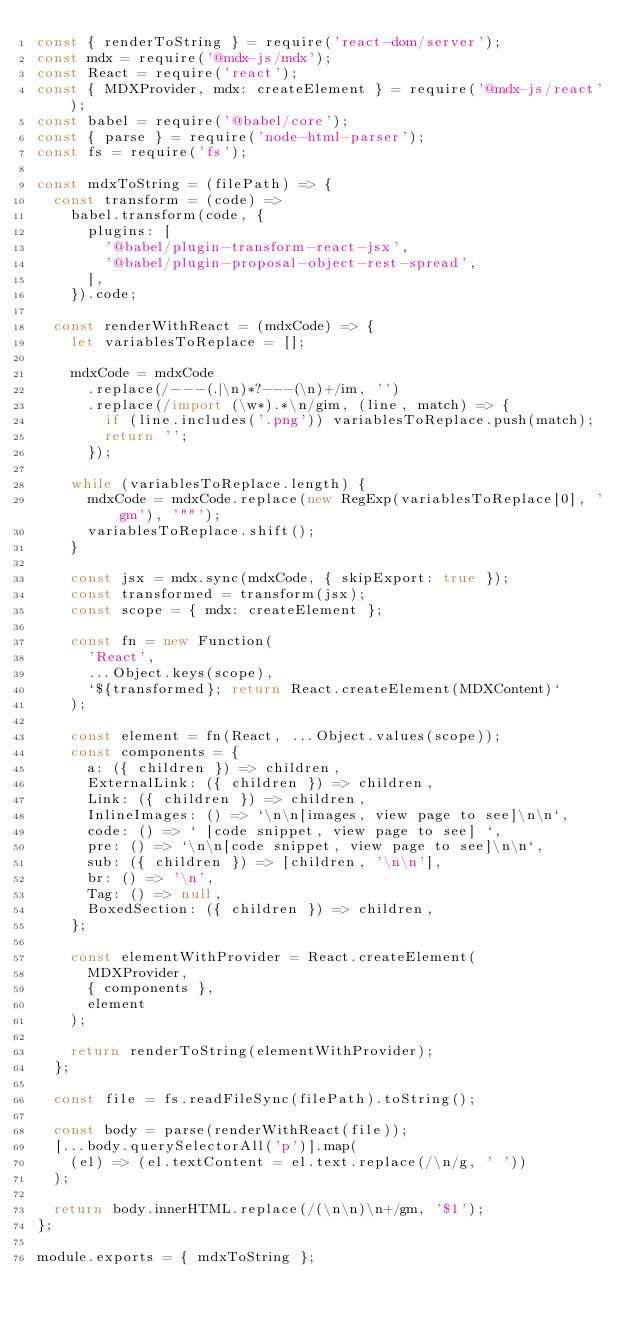Convert code to text. <code><loc_0><loc_0><loc_500><loc_500><_JavaScript_>const { renderToString } = require('react-dom/server');
const mdx = require('@mdx-js/mdx');
const React = require('react');
const { MDXProvider, mdx: createElement } = require('@mdx-js/react');
const babel = require('@babel/core');
const { parse } = require('node-html-parser');
const fs = require('fs');

const mdxToString = (filePath) => {
  const transform = (code) =>
    babel.transform(code, {
      plugins: [
        '@babel/plugin-transform-react-jsx',
        '@babel/plugin-proposal-object-rest-spread',
      ],
    }).code;

  const renderWithReact = (mdxCode) => {
    let variablesToReplace = [];

    mdxCode = mdxCode
      .replace(/---(.|\n)*?---(\n)+/im, '')
      .replace(/import (\w*).*\n/gim, (line, match) => {
        if (line.includes('.png')) variablesToReplace.push(match);
        return '';
      });

    while (variablesToReplace.length) {
      mdxCode = mdxCode.replace(new RegExp(variablesToReplace[0], 'gm'), '""');
      variablesToReplace.shift();
    }

    const jsx = mdx.sync(mdxCode, { skipExport: true });
    const transformed = transform(jsx);
    const scope = { mdx: createElement };

    const fn = new Function(
      'React',
      ...Object.keys(scope),
      `${transformed}; return React.createElement(MDXContent)`
    );

    const element = fn(React, ...Object.values(scope));
    const components = {
      a: ({ children }) => children,
      ExternalLink: ({ children }) => children,
      Link: ({ children }) => children,
      InlineImages: () => `\n\n[images, view page to see]\n\n`,
      code: () => ` [code snippet, view page to see] `,
      pre: () => `\n\n[code snippet, view page to see]\n\n`,
      sub: ({ children }) => [children, '\n\n'],
      br: () => '\n',
      Tag: () => null,
      BoxedSection: ({ children }) => children,
    };

    const elementWithProvider = React.createElement(
      MDXProvider,
      { components },
      element
    );

    return renderToString(elementWithProvider);
  };

  const file = fs.readFileSync(filePath).toString();

  const body = parse(renderWithReact(file));
  [...body.querySelectorAll('p')].map(
    (el) => (el.textContent = el.text.replace(/\n/g, ' '))
  );

  return body.innerHTML.replace(/(\n\n)\n+/gm, '$1');
};

module.exports = { mdxToString };
</code> 